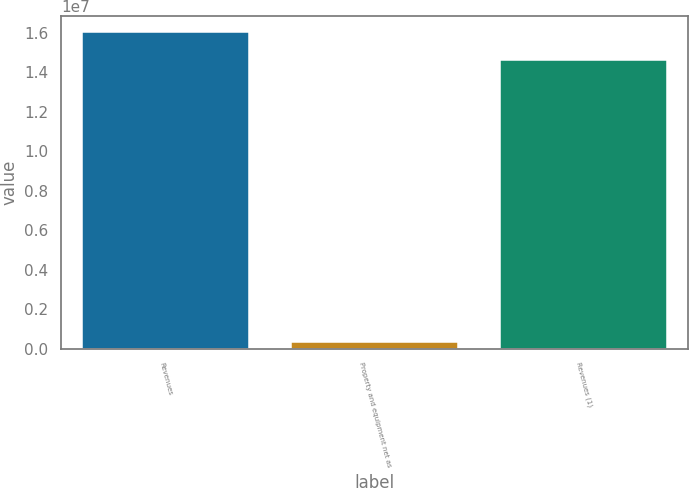<chart> <loc_0><loc_0><loc_500><loc_500><bar_chart><fcel>Revenues<fcel>Property and equipment net as<fcel>Revenues (1)<nl><fcel>1.60584e+07<fcel>354362<fcel>1.46258e+07<nl></chart> 